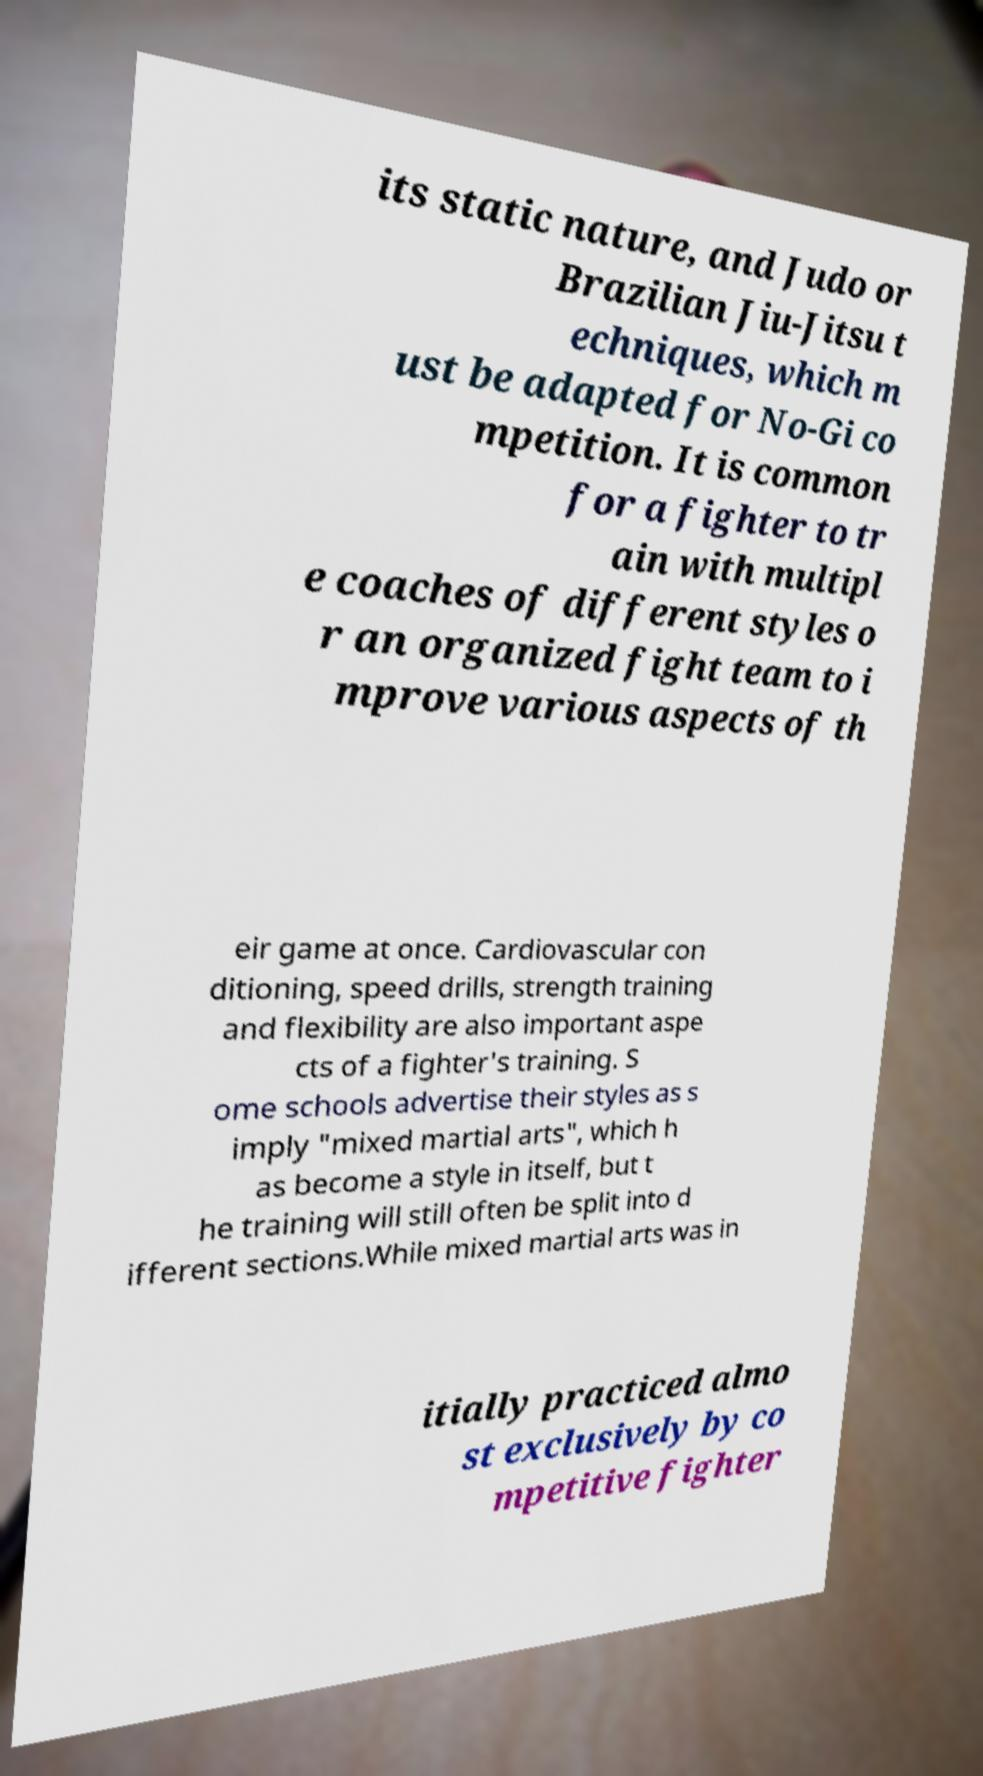Please identify and transcribe the text found in this image. its static nature, and Judo or Brazilian Jiu-Jitsu t echniques, which m ust be adapted for No-Gi co mpetition. It is common for a fighter to tr ain with multipl e coaches of different styles o r an organized fight team to i mprove various aspects of th eir game at once. Cardiovascular con ditioning, speed drills, strength training and flexibility are also important aspe cts of a fighter's training. S ome schools advertise their styles as s imply "mixed martial arts", which h as become a style in itself, but t he training will still often be split into d ifferent sections.While mixed martial arts was in itially practiced almo st exclusively by co mpetitive fighter 